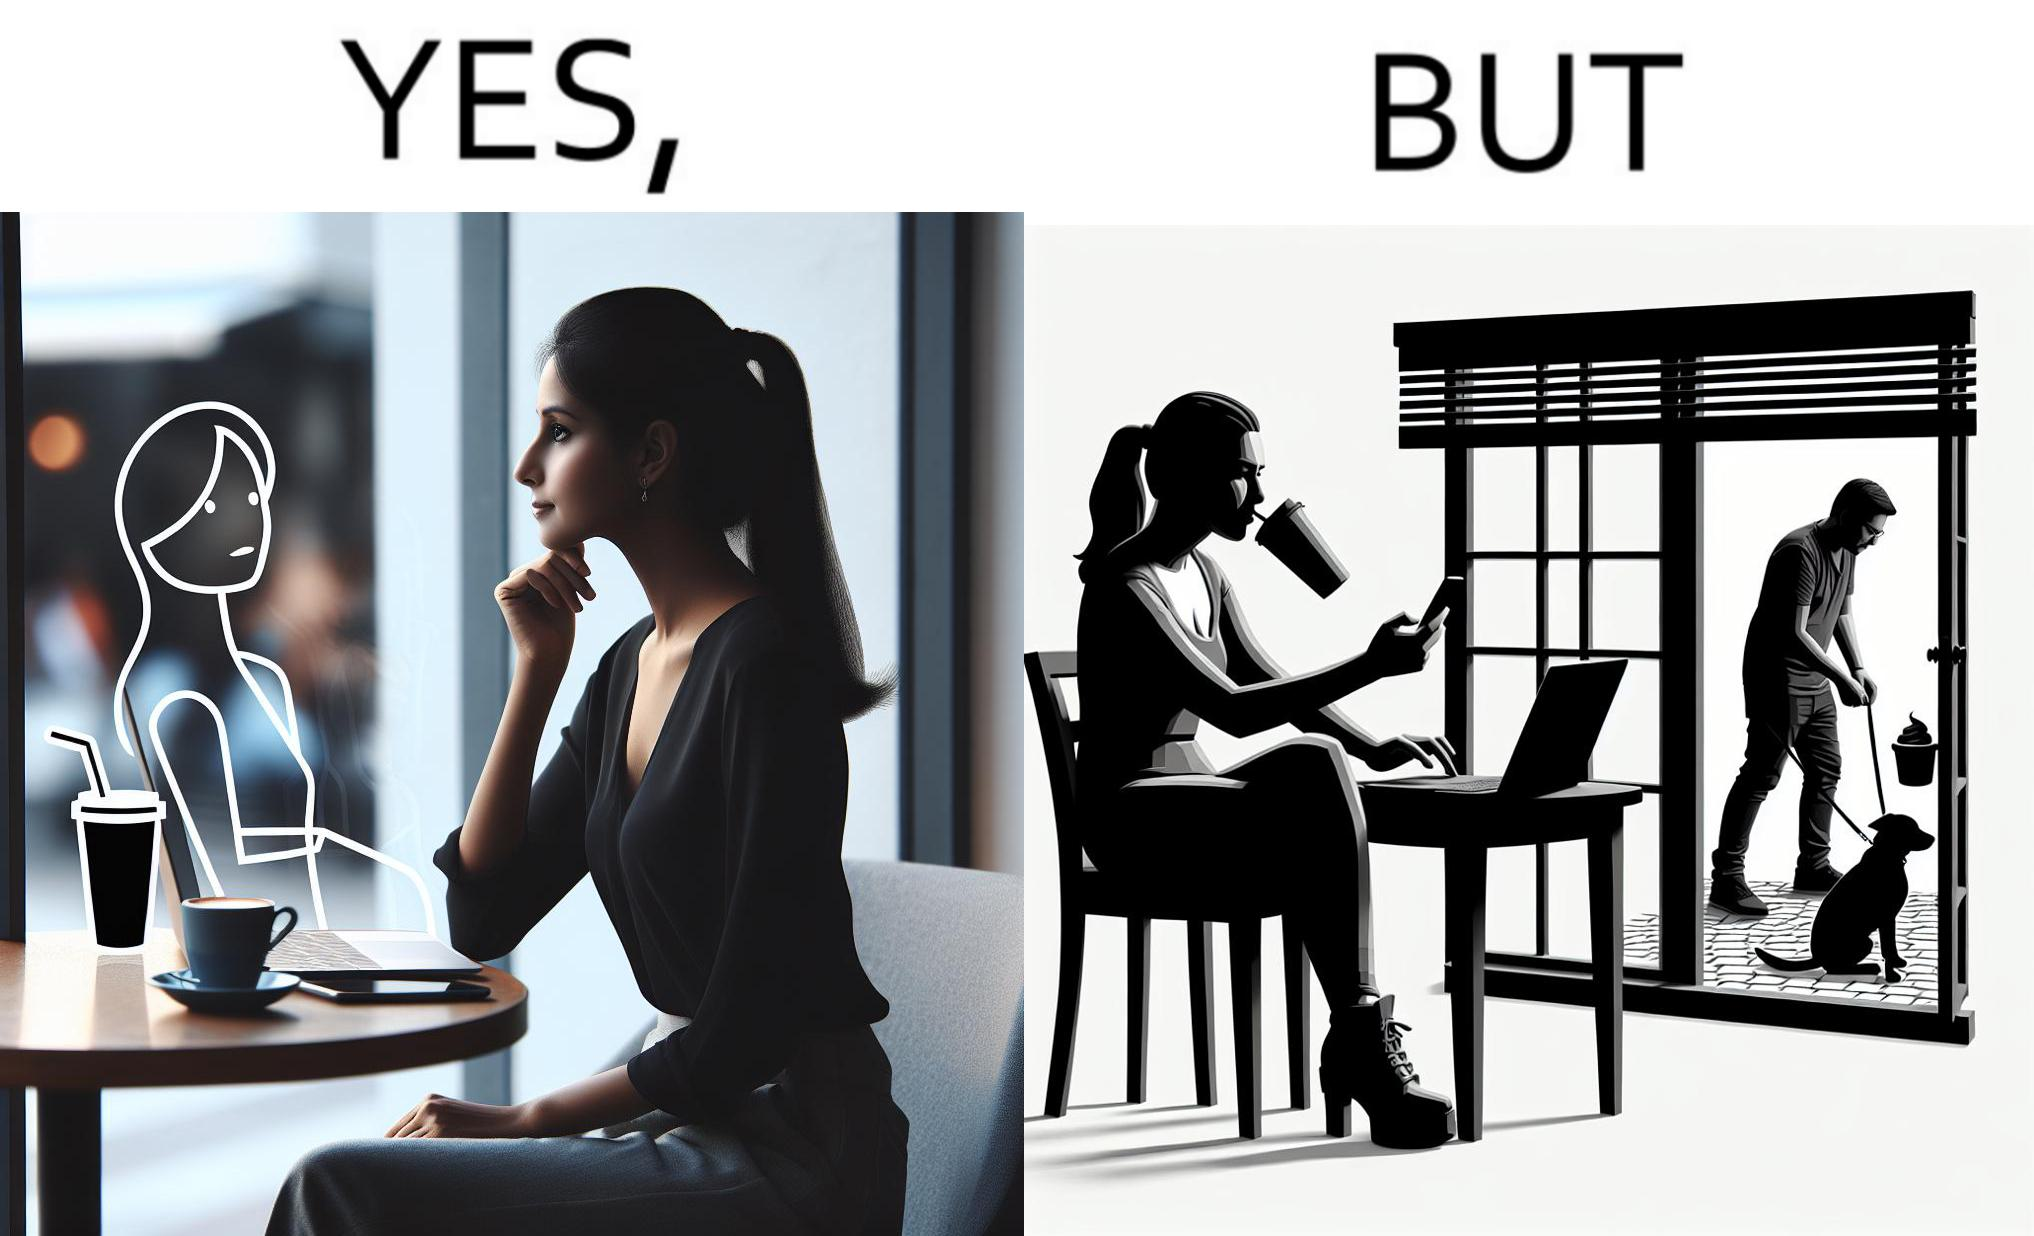What do you see in each half of this image? In the left part of the image: a woman looking through the window from a cafe while enjoying her drink with working on her laptop In the right part of the image: a woman enjoying her drink and working at laptop while looking outside through the window at a person who is out for getting his dog pooped outside 